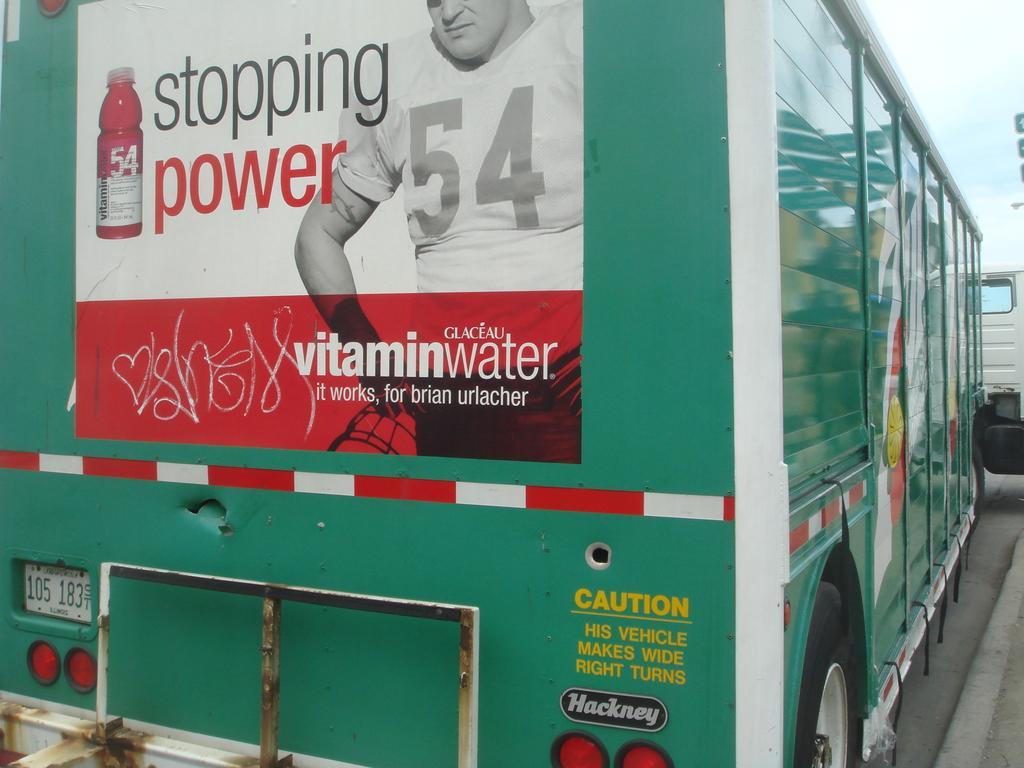Could you give a brief overview of what you see in this image? In this picture we can see a poster on a vehicle. Behind the vehicle where is the sky. On the right side of the image, it looks like another vehicle. 